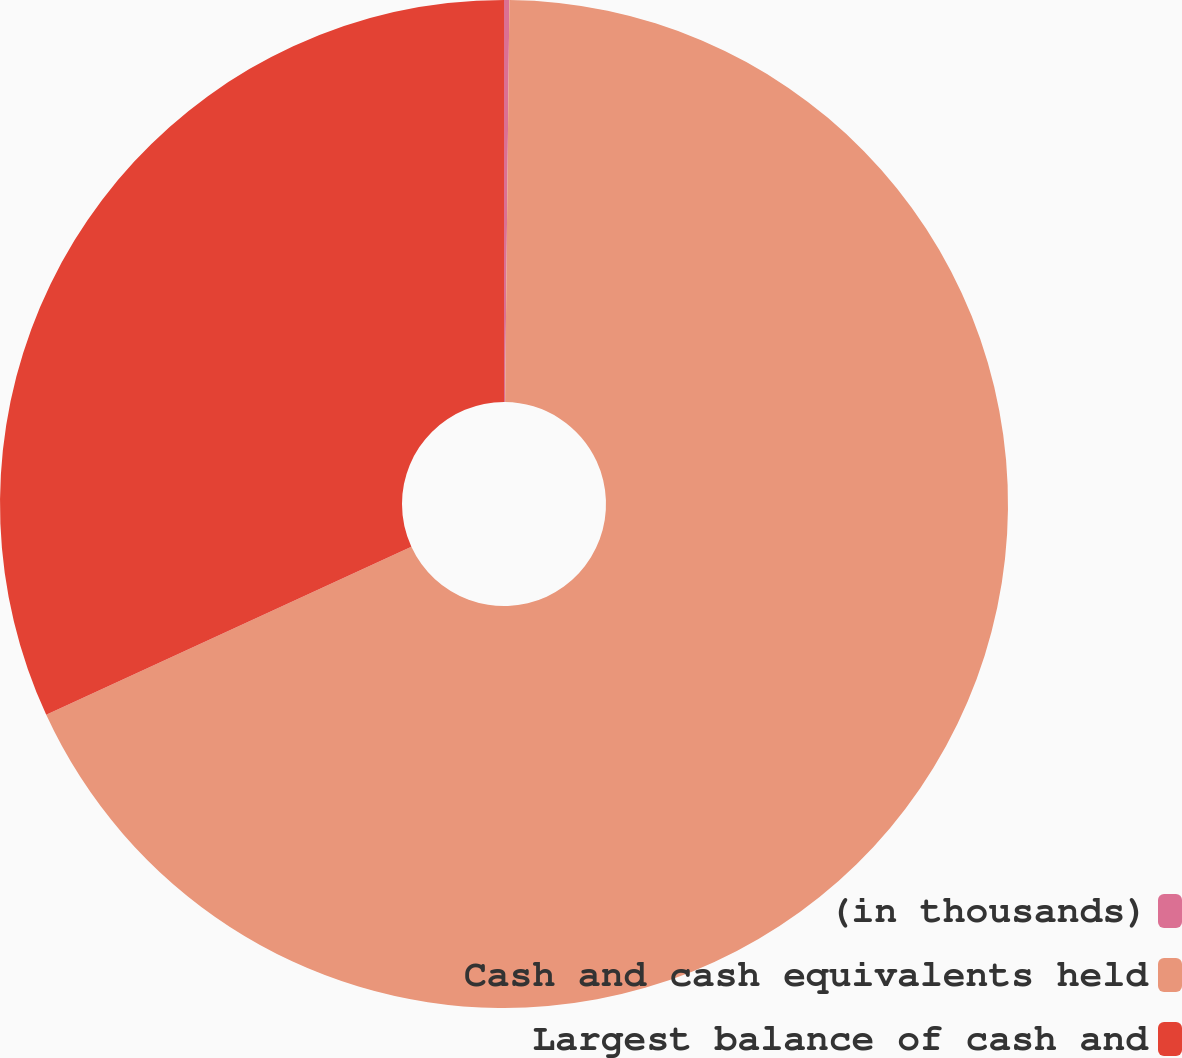Convert chart. <chart><loc_0><loc_0><loc_500><loc_500><pie_chart><fcel>(in thousands)<fcel>Cash and cash equivalents held<fcel>Largest balance of cash and<nl><fcel>0.17%<fcel>67.96%<fcel>31.87%<nl></chart> 